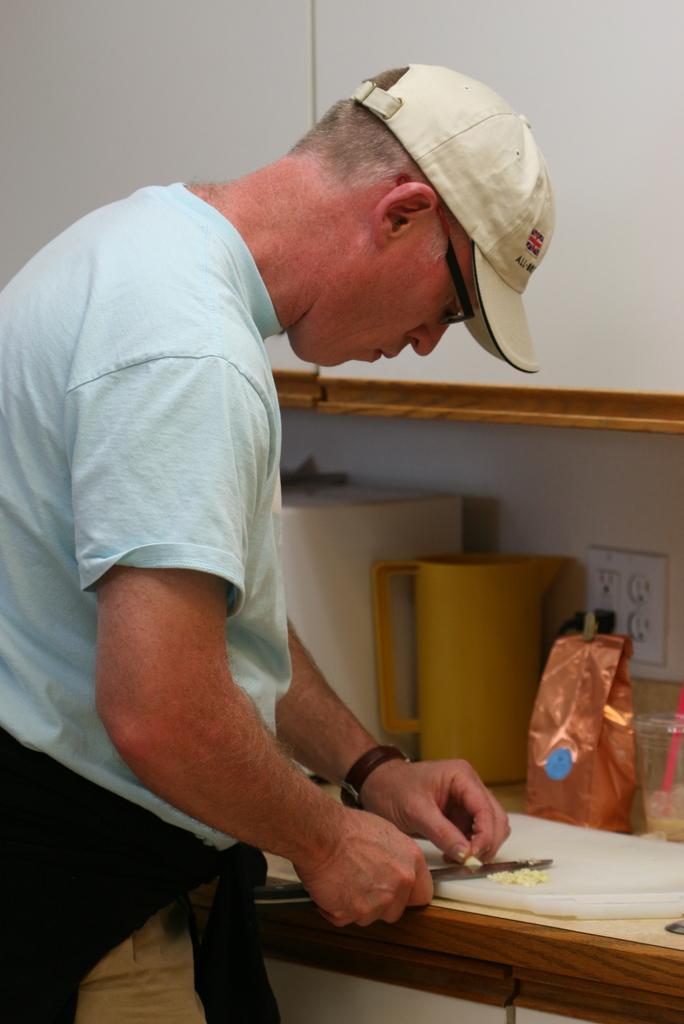Can you describe this image briefly? In this image we can see a man standing and holding a knife in his hand and a there is a chop board placed on the table. On the table we can see jug, switch board, disposal tumbler and polythene cover. 